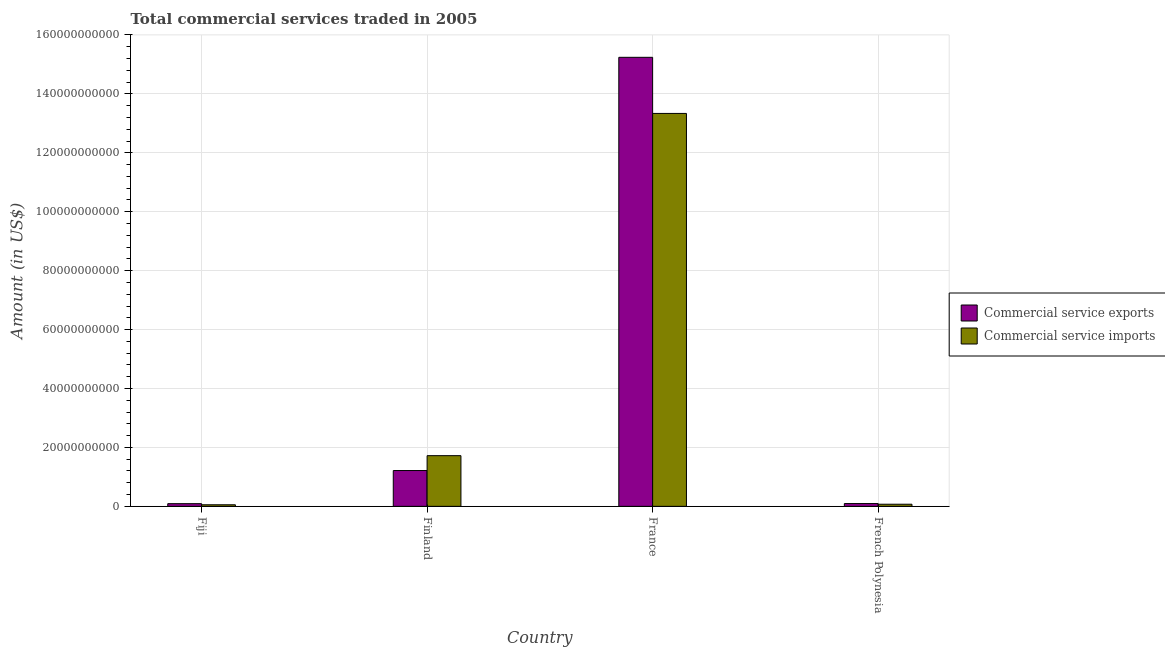Are the number of bars on each tick of the X-axis equal?
Your answer should be very brief. Yes. What is the label of the 4th group of bars from the left?
Your answer should be very brief. French Polynesia. In how many cases, is the number of bars for a given country not equal to the number of legend labels?
Keep it short and to the point. 0. What is the amount of commercial service imports in French Polynesia?
Keep it short and to the point. 7.21e+08. Across all countries, what is the maximum amount of commercial service exports?
Keep it short and to the point. 1.52e+11. Across all countries, what is the minimum amount of commercial service exports?
Offer a very short reply. 9.11e+08. In which country was the amount of commercial service imports minimum?
Ensure brevity in your answer.  Fiji. What is the total amount of commercial service exports in the graph?
Offer a terse response. 1.66e+11. What is the difference between the amount of commercial service exports in Fiji and that in Finland?
Your response must be concise. -1.12e+1. What is the difference between the amount of commercial service exports in French Polynesia and the amount of commercial service imports in France?
Give a very brief answer. -1.32e+11. What is the average amount of commercial service imports per country?
Make the answer very short. 3.80e+1. What is the difference between the amount of commercial service exports and amount of commercial service imports in Fiji?
Your response must be concise. 3.77e+08. In how many countries, is the amount of commercial service imports greater than 52000000000 US$?
Keep it short and to the point. 1. What is the ratio of the amount of commercial service exports in France to that in French Polynesia?
Your answer should be compact. 160.49. Is the difference between the amount of commercial service imports in Fiji and France greater than the difference between the amount of commercial service exports in Fiji and France?
Your answer should be very brief. Yes. What is the difference between the highest and the second highest amount of commercial service imports?
Provide a short and direct response. 1.16e+11. What is the difference between the highest and the lowest amount of commercial service exports?
Ensure brevity in your answer.  1.52e+11. In how many countries, is the amount of commercial service imports greater than the average amount of commercial service imports taken over all countries?
Make the answer very short. 1. What does the 1st bar from the left in French Polynesia represents?
Your response must be concise. Commercial service exports. What does the 1st bar from the right in Fiji represents?
Your response must be concise. Commercial service imports. What is the difference between two consecutive major ticks on the Y-axis?
Your answer should be very brief. 2.00e+1. Does the graph contain any zero values?
Your answer should be compact. No. Does the graph contain grids?
Provide a short and direct response. Yes. Where does the legend appear in the graph?
Keep it short and to the point. Center right. How many legend labels are there?
Your response must be concise. 2. How are the legend labels stacked?
Give a very brief answer. Vertical. What is the title of the graph?
Offer a terse response. Total commercial services traded in 2005. Does "Merchandise imports" appear as one of the legend labels in the graph?
Give a very brief answer. No. What is the label or title of the Y-axis?
Make the answer very short. Amount (in US$). What is the Amount (in US$) of Commercial service exports in Fiji?
Offer a very short reply. 9.11e+08. What is the Amount (in US$) of Commercial service imports in Fiji?
Offer a terse response. 5.34e+08. What is the Amount (in US$) in Commercial service exports in Finland?
Provide a short and direct response. 1.22e+1. What is the Amount (in US$) in Commercial service imports in Finland?
Ensure brevity in your answer.  1.72e+1. What is the Amount (in US$) in Commercial service exports in France?
Keep it short and to the point. 1.52e+11. What is the Amount (in US$) in Commercial service imports in France?
Your response must be concise. 1.33e+11. What is the Amount (in US$) in Commercial service exports in French Polynesia?
Offer a terse response. 9.50e+08. What is the Amount (in US$) in Commercial service imports in French Polynesia?
Make the answer very short. 7.21e+08. Across all countries, what is the maximum Amount (in US$) in Commercial service exports?
Offer a very short reply. 1.52e+11. Across all countries, what is the maximum Amount (in US$) of Commercial service imports?
Your answer should be very brief. 1.33e+11. Across all countries, what is the minimum Amount (in US$) in Commercial service exports?
Offer a very short reply. 9.11e+08. Across all countries, what is the minimum Amount (in US$) of Commercial service imports?
Provide a short and direct response. 5.34e+08. What is the total Amount (in US$) of Commercial service exports in the graph?
Provide a short and direct response. 1.66e+11. What is the total Amount (in US$) in Commercial service imports in the graph?
Make the answer very short. 1.52e+11. What is the difference between the Amount (in US$) in Commercial service exports in Fiji and that in Finland?
Your answer should be compact. -1.12e+1. What is the difference between the Amount (in US$) in Commercial service imports in Fiji and that in Finland?
Provide a short and direct response. -1.67e+1. What is the difference between the Amount (in US$) of Commercial service exports in Fiji and that in France?
Provide a succinct answer. -1.52e+11. What is the difference between the Amount (in US$) in Commercial service imports in Fiji and that in France?
Keep it short and to the point. -1.33e+11. What is the difference between the Amount (in US$) of Commercial service exports in Fiji and that in French Polynesia?
Offer a terse response. -3.82e+07. What is the difference between the Amount (in US$) in Commercial service imports in Fiji and that in French Polynesia?
Provide a short and direct response. -1.87e+08. What is the difference between the Amount (in US$) of Commercial service exports in Finland and that in France?
Keep it short and to the point. -1.40e+11. What is the difference between the Amount (in US$) of Commercial service imports in Finland and that in France?
Your answer should be very brief. -1.16e+11. What is the difference between the Amount (in US$) in Commercial service exports in Finland and that in French Polynesia?
Offer a very short reply. 1.12e+1. What is the difference between the Amount (in US$) of Commercial service imports in Finland and that in French Polynesia?
Keep it short and to the point. 1.65e+1. What is the difference between the Amount (in US$) in Commercial service exports in France and that in French Polynesia?
Your answer should be very brief. 1.51e+11. What is the difference between the Amount (in US$) of Commercial service imports in France and that in French Polynesia?
Provide a succinct answer. 1.33e+11. What is the difference between the Amount (in US$) of Commercial service exports in Fiji and the Amount (in US$) of Commercial service imports in Finland?
Your answer should be very brief. -1.63e+1. What is the difference between the Amount (in US$) in Commercial service exports in Fiji and the Amount (in US$) in Commercial service imports in France?
Give a very brief answer. -1.32e+11. What is the difference between the Amount (in US$) of Commercial service exports in Fiji and the Amount (in US$) of Commercial service imports in French Polynesia?
Offer a terse response. 1.91e+08. What is the difference between the Amount (in US$) of Commercial service exports in Finland and the Amount (in US$) of Commercial service imports in France?
Keep it short and to the point. -1.21e+11. What is the difference between the Amount (in US$) of Commercial service exports in Finland and the Amount (in US$) of Commercial service imports in French Polynesia?
Your answer should be very brief. 1.14e+1. What is the difference between the Amount (in US$) in Commercial service exports in France and the Amount (in US$) in Commercial service imports in French Polynesia?
Make the answer very short. 1.52e+11. What is the average Amount (in US$) of Commercial service exports per country?
Ensure brevity in your answer.  4.16e+1. What is the average Amount (in US$) of Commercial service imports per country?
Your response must be concise. 3.80e+1. What is the difference between the Amount (in US$) in Commercial service exports and Amount (in US$) in Commercial service imports in Fiji?
Provide a short and direct response. 3.77e+08. What is the difference between the Amount (in US$) of Commercial service exports and Amount (in US$) of Commercial service imports in Finland?
Offer a terse response. -5.05e+09. What is the difference between the Amount (in US$) of Commercial service exports and Amount (in US$) of Commercial service imports in France?
Offer a very short reply. 1.90e+1. What is the difference between the Amount (in US$) in Commercial service exports and Amount (in US$) in Commercial service imports in French Polynesia?
Keep it short and to the point. 2.29e+08. What is the ratio of the Amount (in US$) in Commercial service exports in Fiji to that in Finland?
Offer a terse response. 0.07. What is the ratio of the Amount (in US$) in Commercial service imports in Fiji to that in Finland?
Provide a short and direct response. 0.03. What is the ratio of the Amount (in US$) of Commercial service exports in Fiji to that in France?
Your answer should be very brief. 0.01. What is the ratio of the Amount (in US$) of Commercial service imports in Fiji to that in France?
Your answer should be compact. 0. What is the ratio of the Amount (in US$) in Commercial service exports in Fiji to that in French Polynesia?
Ensure brevity in your answer.  0.96. What is the ratio of the Amount (in US$) in Commercial service imports in Fiji to that in French Polynesia?
Provide a succinct answer. 0.74. What is the ratio of the Amount (in US$) in Commercial service exports in Finland to that in France?
Provide a succinct answer. 0.08. What is the ratio of the Amount (in US$) of Commercial service imports in Finland to that in France?
Your answer should be very brief. 0.13. What is the ratio of the Amount (in US$) in Commercial service exports in Finland to that in French Polynesia?
Ensure brevity in your answer.  12.8. What is the ratio of the Amount (in US$) in Commercial service imports in Finland to that in French Polynesia?
Offer a terse response. 23.87. What is the ratio of the Amount (in US$) of Commercial service exports in France to that in French Polynesia?
Your answer should be compact. 160.49. What is the ratio of the Amount (in US$) of Commercial service imports in France to that in French Polynesia?
Ensure brevity in your answer.  185.06. What is the difference between the highest and the second highest Amount (in US$) of Commercial service exports?
Keep it short and to the point. 1.40e+11. What is the difference between the highest and the second highest Amount (in US$) of Commercial service imports?
Your answer should be very brief. 1.16e+11. What is the difference between the highest and the lowest Amount (in US$) of Commercial service exports?
Offer a terse response. 1.52e+11. What is the difference between the highest and the lowest Amount (in US$) of Commercial service imports?
Ensure brevity in your answer.  1.33e+11. 